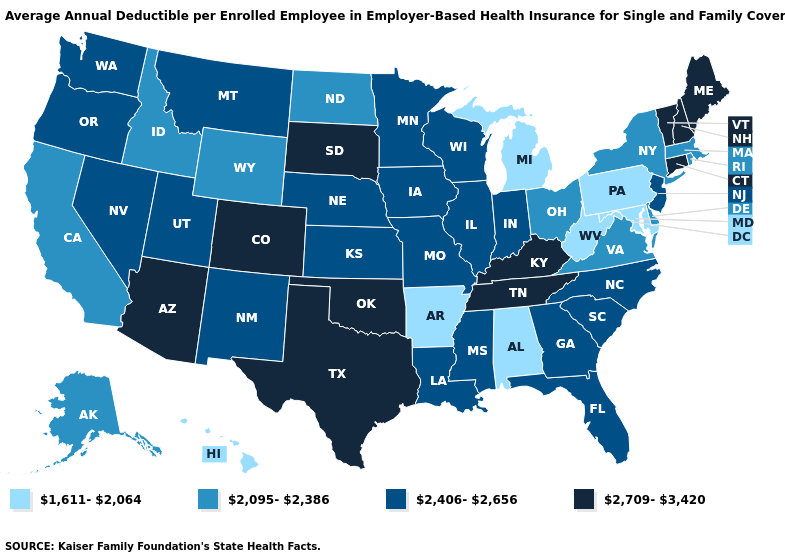Name the states that have a value in the range 1,611-2,064?
Be succinct. Alabama, Arkansas, Hawaii, Maryland, Michigan, Pennsylvania, West Virginia. Name the states that have a value in the range 1,611-2,064?
Keep it brief. Alabama, Arkansas, Hawaii, Maryland, Michigan, Pennsylvania, West Virginia. What is the highest value in the USA?
Short answer required. 2,709-3,420. What is the value of Texas?
Keep it brief. 2,709-3,420. What is the value of Iowa?
Be succinct. 2,406-2,656. Among the states that border Illinois , which have the lowest value?
Give a very brief answer. Indiana, Iowa, Missouri, Wisconsin. Name the states that have a value in the range 2,709-3,420?
Answer briefly. Arizona, Colorado, Connecticut, Kentucky, Maine, New Hampshire, Oklahoma, South Dakota, Tennessee, Texas, Vermont. What is the value of Maine?
Give a very brief answer. 2,709-3,420. Name the states that have a value in the range 2,709-3,420?
Keep it brief. Arizona, Colorado, Connecticut, Kentucky, Maine, New Hampshire, Oklahoma, South Dakota, Tennessee, Texas, Vermont. Which states hav the highest value in the MidWest?
Answer briefly. South Dakota. Name the states that have a value in the range 1,611-2,064?
Answer briefly. Alabama, Arkansas, Hawaii, Maryland, Michigan, Pennsylvania, West Virginia. Name the states that have a value in the range 2,095-2,386?
Be succinct. Alaska, California, Delaware, Idaho, Massachusetts, New York, North Dakota, Ohio, Rhode Island, Virginia, Wyoming. Does North Carolina have the same value as Arkansas?
Be succinct. No. Which states have the highest value in the USA?
Keep it brief. Arizona, Colorado, Connecticut, Kentucky, Maine, New Hampshire, Oklahoma, South Dakota, Tennessee, Texas, Vermont. Name the states that have a value in the range 2,406-2,656?
Quick response, please. Florida, Georgia, Illinois, Indiana, Iowa, Kansas, Louisiana, Minnesota, Mississippi, Missouri, Montana, Nebraska, Nevada, New Jersey, New Mexico, North Carolina, Oregon, South Carolina, Utah, Washington, Wisconsin. 